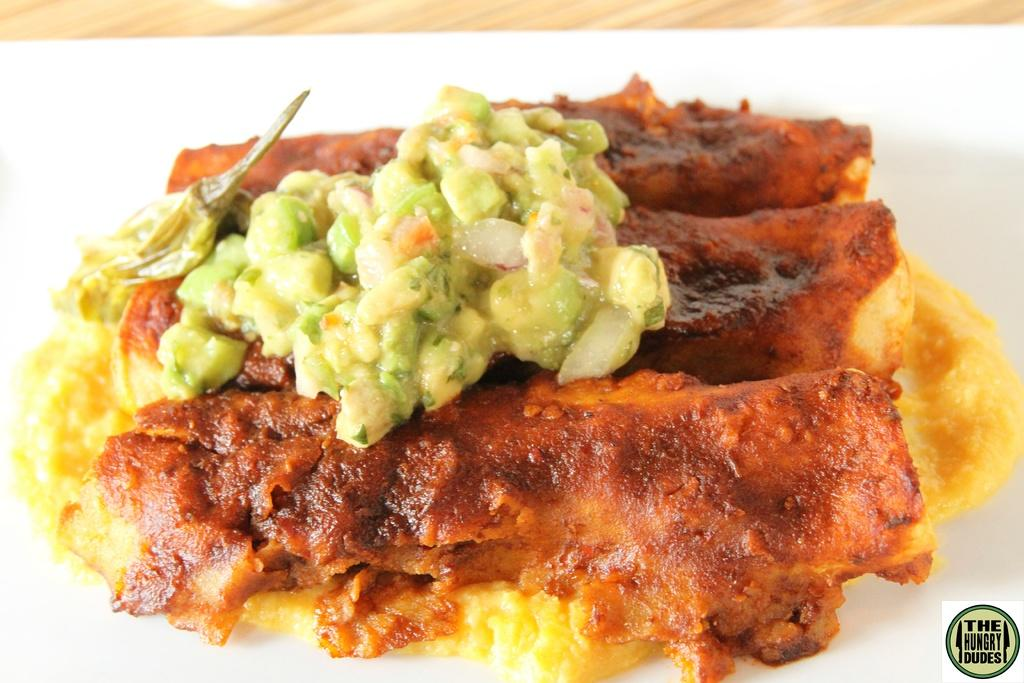What colors are present in the food in the image? The food in the image has red, yellow, and green colors. What is the color of the surface on which the food is placed? The food is on a white surface. What can be seen in the background of the image? There is a brown color table in the background of the image. How many times did the person attempt to stop the watch in the image? There is no watch present in the image, so it is not possible to answer that question. 